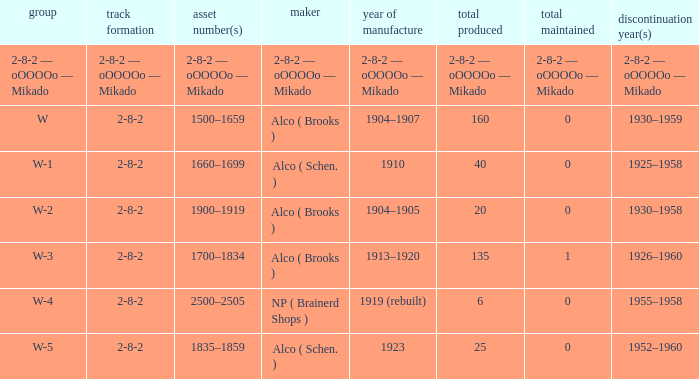What is the locomotive class that has a wheel arrangement of 2-8-2 and a quantity made of 25? W-5. 